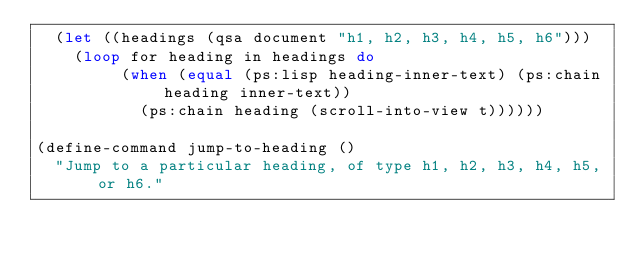<code> <loc_0><loc_0><loc_500><loc_500><_Lisp_>  (let ((headings (qsa document "h1, h2, h3, h4, h5, h6")))
    (loop for heading in headings do
         (when (equal (ps:lisp heading-inner-text) (ps:chain heading inner-text))
           (ps:chain heading (scroll-into-view t))))))

(define-command jump-to-heading ()
  "Jump to a particular heading, of type h1, h2, h3, h4, h5, or h6."</code> 